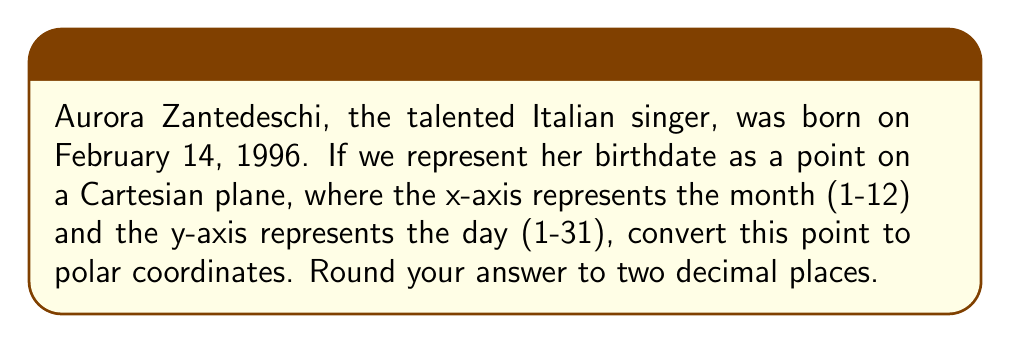Can you solve this math problem? To solve this problem, let's follow these steps:

1. Identify the Cartesian coordinates:
   x = 2 (February is the 2nd month)
   y = 14 (14th day of the month)

2. The formula to convert from Cartesian coordinates (x, y) to polar coordinates (r, θ) is:
   $r = \sqrt{x^2 + y^2}$
   $\theta = \tan^{-1}(\frac{y}{x})$

3. Calculate r:
   $r = \sqrt{2^2 + 14^2} = \sqrt{4 + 196} = \sqrt{200} = 10\sqrt{2} \approx 14.14$

4. Calculate θ:
   $\theta = \tan^{-1}(\frac{14}{2}) = \tan^{-1}(7) \approx 1.43$ radians

5. Convert θ to degrees:
   $1.43 \text{ radians} \times \frac{180°}{\pi} \approx 81.87°$

Therefore, Aurora Zantedeschi's birthdate in polar coordinates is approximately (14.14, 81.87°).

[asy]
import geometry;

size(200);
real r = 14.14;
real theta = 81.87 * pi / 180;

draw((-1,0)--(15,0), arrow=Arrow(TeXHead));
draw((0,-1)--(0,15), arrow=Arrow(TeXHead));

draw((0,0)--(r*cos(theta), r*sin(theta)), arrow=Arrow(TeXHead), red);
draw(arc((0,0), 3, 0, theta), blue);

label("$x$", (15,0), E);
label("$y$", (0,15), N);
label("$r$", (r*cos(theta)/2, r*sin(theta)/2), NW, red);
label("$\theta$", (2,1), blue);
label("(2, 14)", (2,14), NE);

dot((2,14));
[/asy]
Answer: $(14.14, 81.87°)$ 